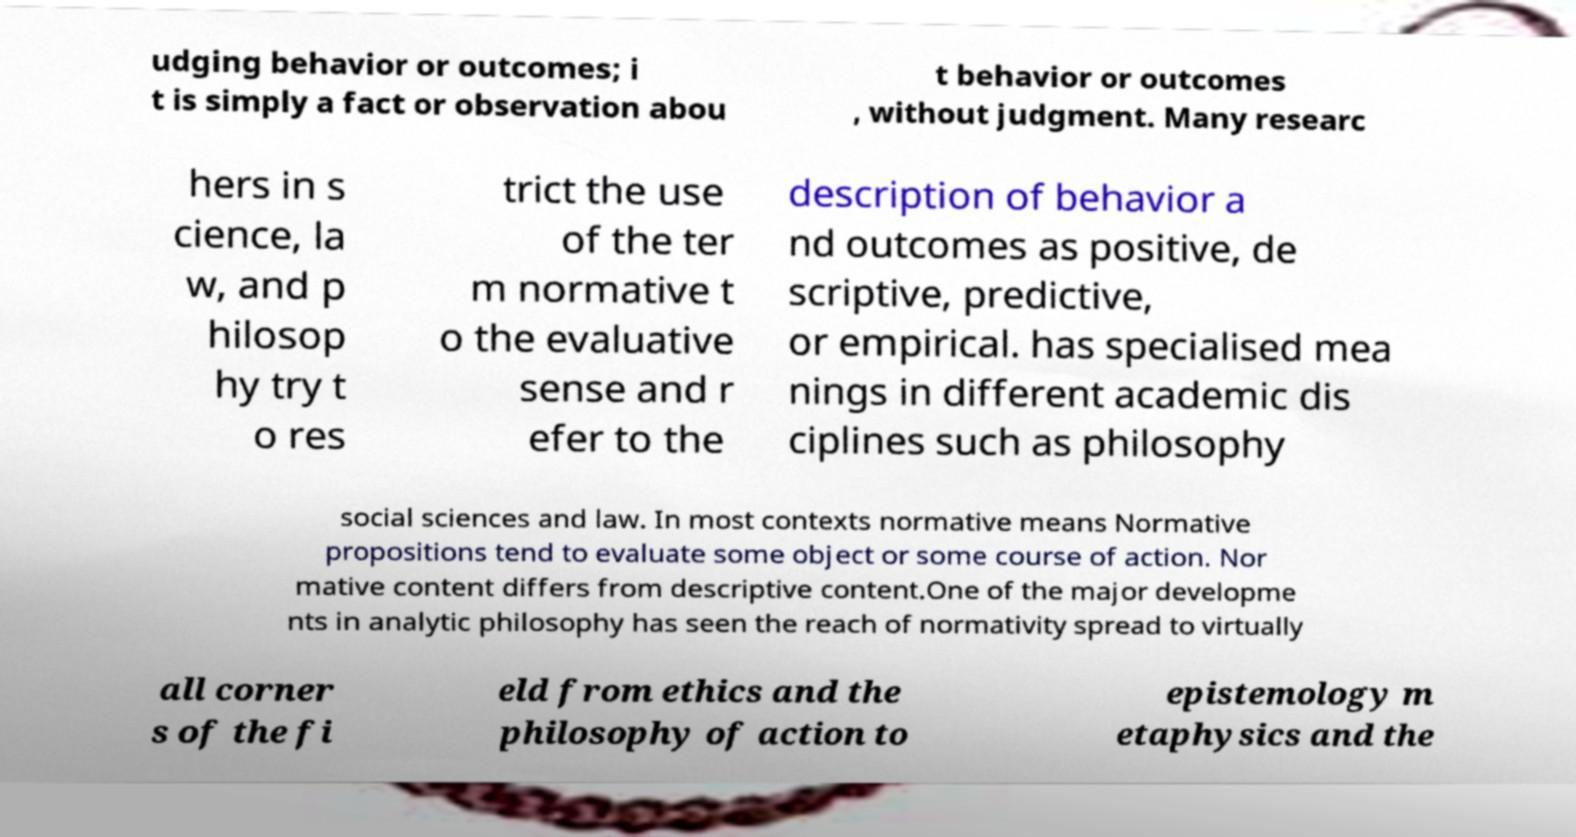Can you accurately transcribe the text from the provided image for me? udging behavior or outcomes; i t is simply a fact or observation abou t behavior or outcomes , without judgment. Many researc hers in s cience, la w, and p hilosop hy try t o res trict the use of the ter m normative t o the evaluative sense and r efer to the description of behavior a nd outcomes as positive, de scriptive, predictive, or empirical. has specialised mea nings in different academic dis ciplines such as philosophy social sciences and law. In most contexts normative means Normative propositions tend to evaluate some object or some course of action. Nor mative content differs from descriptive content.One of the major developme nts in analytic philosophy has seen the reach of normativity spread to virtually all corner s of the fi eld from ethics and the philosophy of action to epistemology m etaphysics and the 